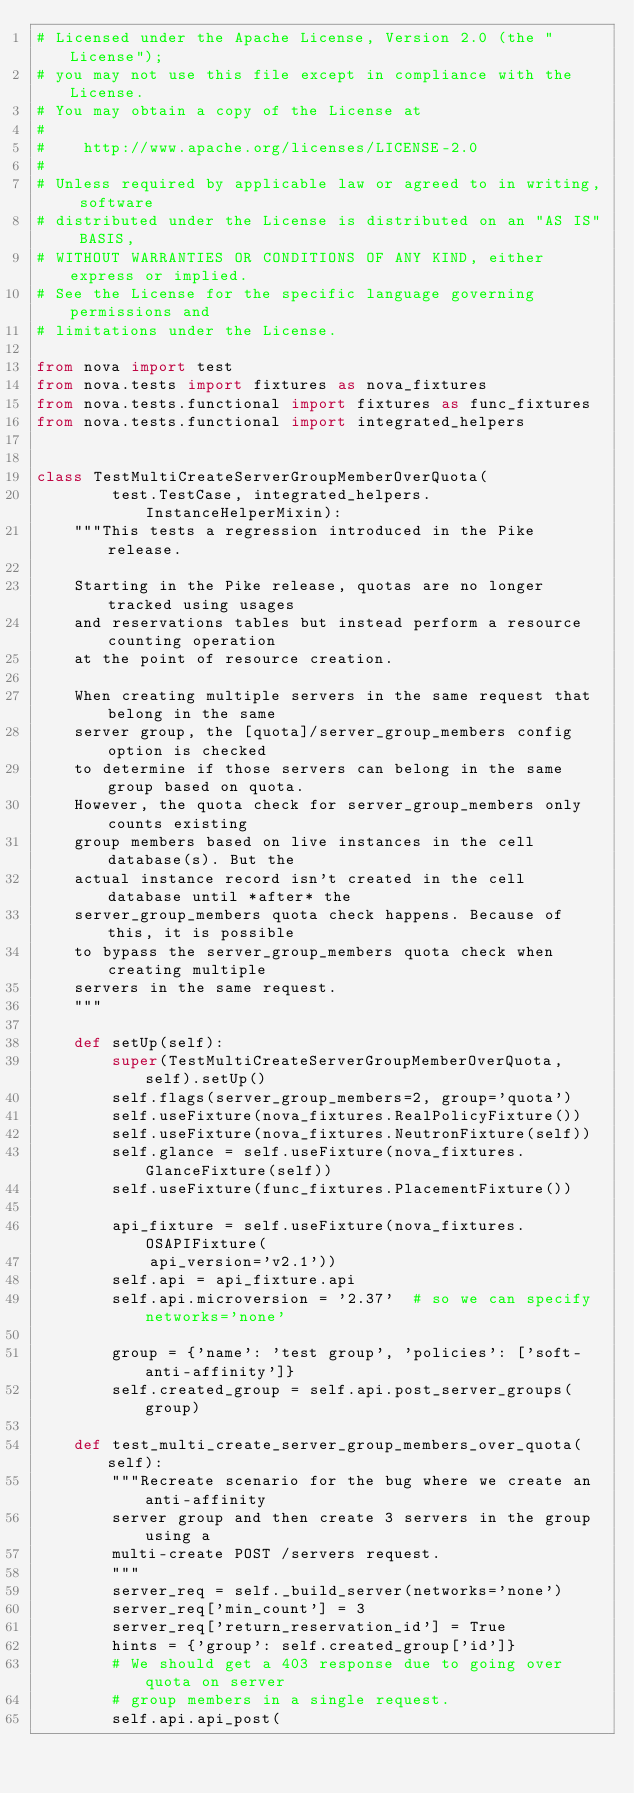<code> <loc_0><loc_0><loc_500><loc_500><_Python_># Licensed under the Apache License, Version 2.0 (the "License");
# you may not use this file except in compliance with the License.
# You may obtain a copy of the License at
#
#    http://www.apache.org/licenses/LICENSE-2.0
#
# Unless required by applicable law or agreed to in writing, software
# distributed under the License is distributed on an "AS IS" BASIS,
# WITHOUT WARRANTIES OR CONDITIONS OF ANY KIND, either express or implied.
# See the License for the specific language governing permissions and
# limitations under the License.

from nova import test
from nova.tests import fixtures as nova_fixtures
from nova.tests.functional import fixtures as func_fixtures
from nova.tests.functional import integrated_helpers


class TestMultiCreateServerGroupMemberOverQuota(
        test.TestCase, integrated_helpers.InstanceHelperMixin):
    """This tests a regression introduced in the Pike release.

    Starting in the Pike release, quotas are no longer tracked using usages
    and reservations tables but instead perform a resource counting operation
    at the point of resource creation.

    When creating multiple servers in the same request that belong in the same
    server group, the [quota]/server_group_members config option is checked
    to determine if those servers can belong in the same group based on quota.
    However, the quota check for server_group_members only counts existing
    group members based on live instances in the cell database(s). But the
    actual instance record isn't created in the cell database until *after* the
    server_group_members quota check happens. Because of this, it is possible
    to bypass the server_group_members quota check when creating multiple
    servers in the same request.
    """

    def setUp(self):
        super(TestMultiCreateServerGroupMemberOverQuota, self).setUp()
        self.flags(server_group_members=2, group='quota')
        self.useFixture(nova_fixtures.RealPolicyFixture())
        self.useFixture(nova_fixtures.NeutronFixture(self))
        self.glance = self.useFixture(nova_fixtures.GlanceFixture(self))
        self.useFixture(func_fixtures.PlacementFixture())

        api_fixture = self.useFixture(nova_fixtures.OSAPIFixture(
            api_version='v2.1'))
        self.api = api_fixture.api
        self.api.microversion = '2.37'  # so we can specify networks='none'

        group = {'name': 'test group', 'policies': ['soft-anti-affinity']}
        self.created_group = self.api.post_server_groups(group)

    def test_multi_create_server_group_members_over_quota(self):
        """Recreate scenario for the bug where we create an anti-affinity
        server group and then create 3 servers in the group using a
        multi-create POST /servers request.
        """
        server_req = self._build_server(networks='none')
        server_req['min_count'] = 3
        server_req['return_reservation_id'] = True
        hints = {'group': self.created_group['id']}
        # We should get a 403 response due to going over quota on server
        # group members in a single request.
        self.api.api_post(</code> 